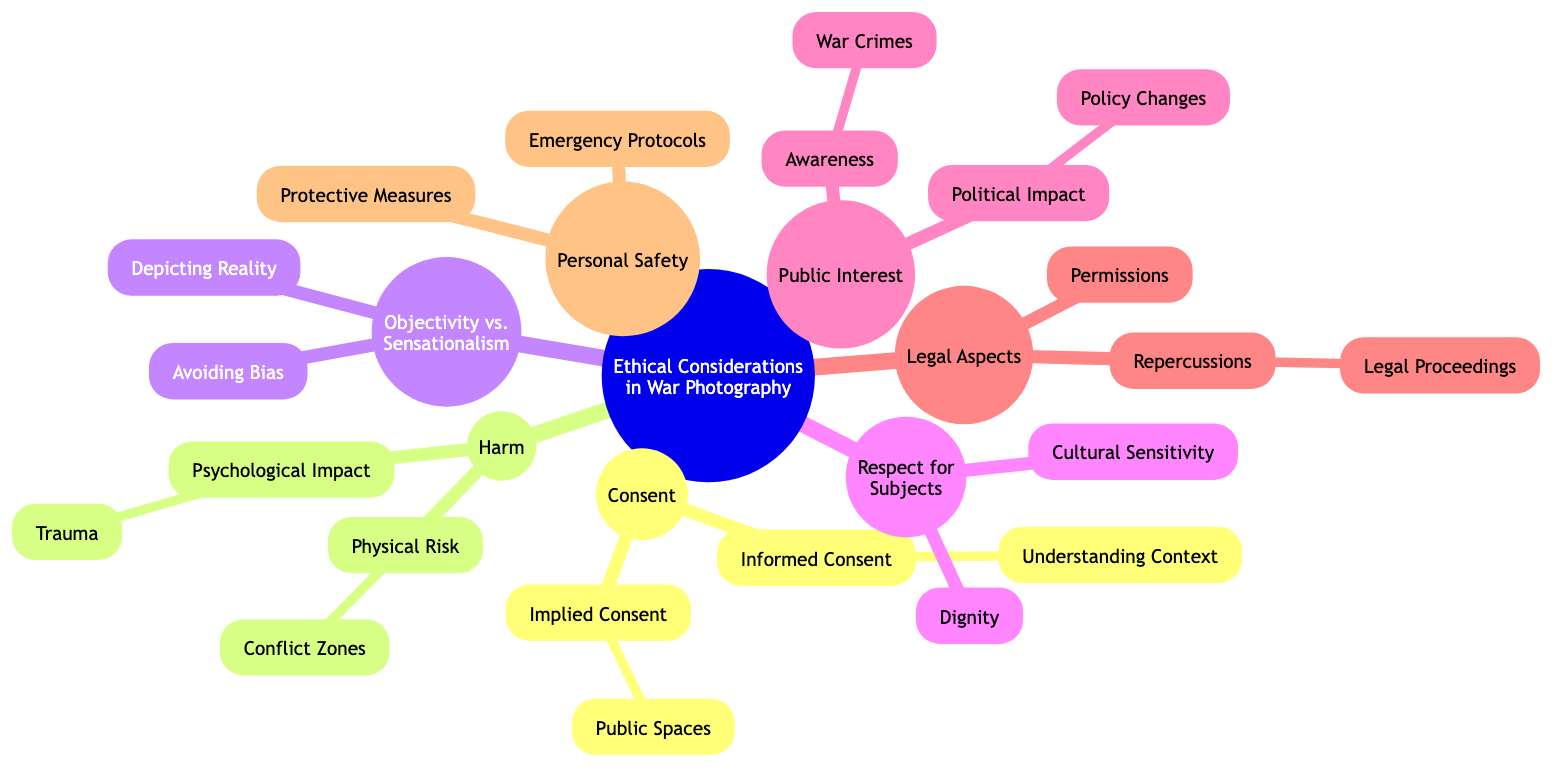What is the main title of the diagram? The main title of the diagram is located at the root node and describes the overall theme of the mind map, which is about ethical considerations in a specific field, namely war photography.
Answer: Ethical Considerations and Dilemmas in War Photography How many main branches are there in the diagram? The diagram features six main branches that emanate from the root node, each representing a different aspect of ethical considerations in war photography. Counting these branches provides the total number.
Answer: 6 What is the sub-branch under “Consent”? The "Consent" main branch has two sub-branches, "Informed Consent" and "Implied Consent." The question asks for one of these sub-branches specifically, where "Informed Consent" is listed first in the diagram.
Answer: Informed Consent Which branch addresses the issue of psychological impact? Looking at the "Harm" main branch, there are two sub-branches associated with it. One of them is specifically labeled “Psychological Impact,” indicating that it covers issues related to psychological effects like trauma in war photography.
Answer: Psychological Impact What is the relationship between “Public Interest” and “Policy Changes”? Under the main branch "Public Interest," the “Political Impact” sub-branch contains “Policy Changes.” The relationship here indicates that awareness raised by war photography can lead to changes in policy, thus showing a direct connection between the two sub-branches.
Answer: Political Impact What ethical concern does “Dignity” relate to? “Dignity” is a sub-branch found under the "Respect for Subjects" main branch, which focuses on treating subjects with respect and ensuring their dignity is preserved while photographing them in war zones.
Answer: Respect for Subjects How many levels deep is the sub-branch "Understanding Context"? To determine the depth, we follow the path from the root down to "Understanding Context." The levels are: Root → Consent → Informed Consent → Understanding Context, making it three levels deep.
Answer: 3 Which branch mentions war crimes? The "Awareness" sub-branch under the main branch "Public Interest" specifically mentions "War Crimes," indicating that this ethical consideration addresses the documentation and reporting of such crimes in war photography.
Answer: Awareness What is the primary focus of “Protective Measures”? “Protective Measures” is found under the "Personal Safety" main branch, which highlights the importance of safety measures taken by war photographers to mitigate risks associated with their work. Therefore, the primary focus is on the safety of photographers themselves.
Answer: Personal Safety What are the repercussions highlighted in the diagram? Under the "Legal Aspects" main branch, within the sub-branch "Repercussions," there is a further sub-branch titled "Legal Proceedings," detailing the possible legal consequences faced by war photographers related to their work.
Answer: Legal Proceedings 